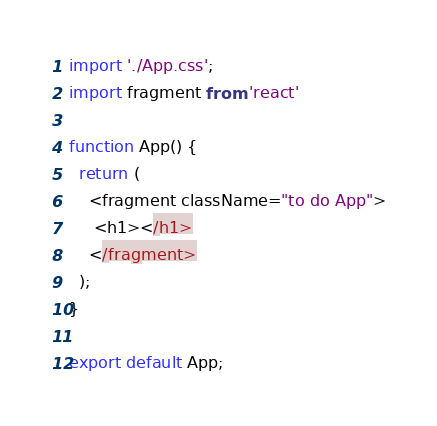<code> <loc_0><loc_0><loc_500><loc_500><_JavaScript_>import './App.css';
import fragment from 'react'

function App() {
  return (
    <fragment className="to do App">
     <h1></h1>
    </fragment>
  );
}

export default App;
</code> 